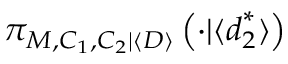<formula> <loc_0><loc_0><loc_500><loc_500>\pi _ { M , C _ { 1 } , C _ { 2 } | \langle D \rangle } \left ( \cdot | \langle d _ { 2 } ^ { * } \rangle \right )</formula> 